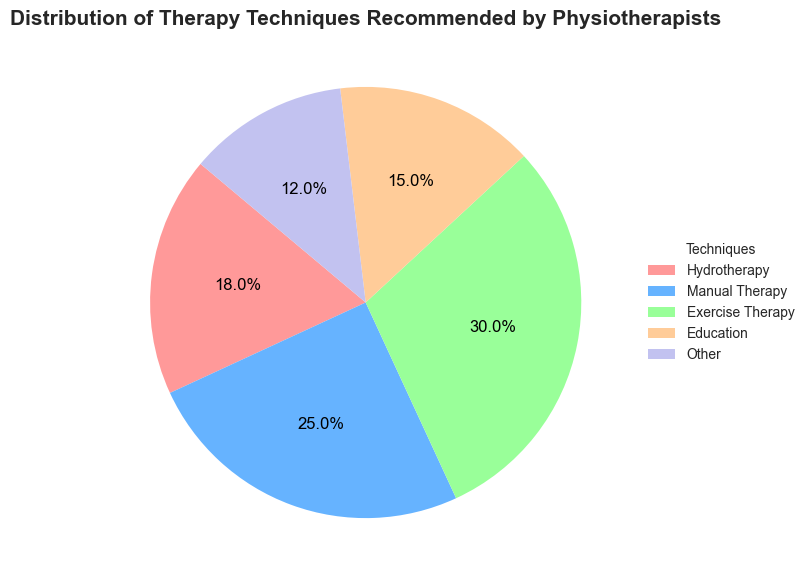How much more popular is Exercise Therapy compared to Education? Exercise Therapy accounts for 30% and Education accounts for 15% of the recommended techniques. The difference is 30% - 15% = 15%.
Answer: 15% Which therapy technique is recommended the least and by how much compared to Hydrotherapy? "Other" is the least recommended therapy technique at 12%, compared to Hydrotherapy at 18%. The difference is 18% - 12% = 6%.
Answer: "Other," by 6% What percentage of techniques are made up of Manual Therapy and Education combined? Manual Therapy is 25% and Education is 15%. Together, they make up 25% + 15% = 40%.
Answer: 40% Which technique has the second highest recommendation? The second highest recommended technique is Manual Therapy at 25%, with Exercise Therapy being the highest at 30%.
Answer: Manual Therapy What is the combined percentage of the two least recommended techniques? Education at 15% and Other at 12% are the two least recommended techniques. Combined, they make up 15% + 12% = 27%.
Answer: 27% Which segment is represented by the blue color, and what percentage does it account for? The blue color represents Manual Therapy, which accounts for 25% of the recommended techniques.
Answer: Manual Therapy, 25% How does the percentage of Hydrotherapy compare to Manual Therapy? Hydrotherapy is 18% and Manual Therapy is 25%, meaning Manual Therapy is 7% more than Hydrotherapy.
Answer: Manual Therapy is 7% more Which techniques together make up more than half of the total recommendations? Exercise Therapy is 30% and Manual Therapy is 25%, together making up 55%, which is more than half of the total.
Answer: Exercise Therapy and Manual Therapy What is the percentage difference between the most and least recommended techniques? Exercise Therapy is the most recommended at 30%, and Other is the least at 12%. The difference is 30% - 12% = 18%.
Answer: 18% If we were to recommend an additional 10% of Exercise Therapy, what would its new percentage be? Exercise Therapy currently accounts for 30%. Adding 10% would result in 30% + 10% = 40%.
Answer: 40% 